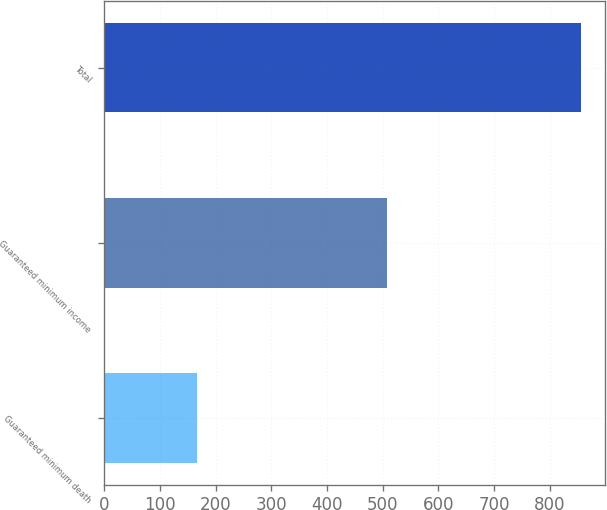Convert chart. <chart><loc_0><loc_0><loc_500><loc_500><bar_chart><fcel>Guaranteed minimum death<fcel>Guaranteed minimum income<fcel>Total<nl><fcel>167<fcel>507<fcel>856<nl></chart> 